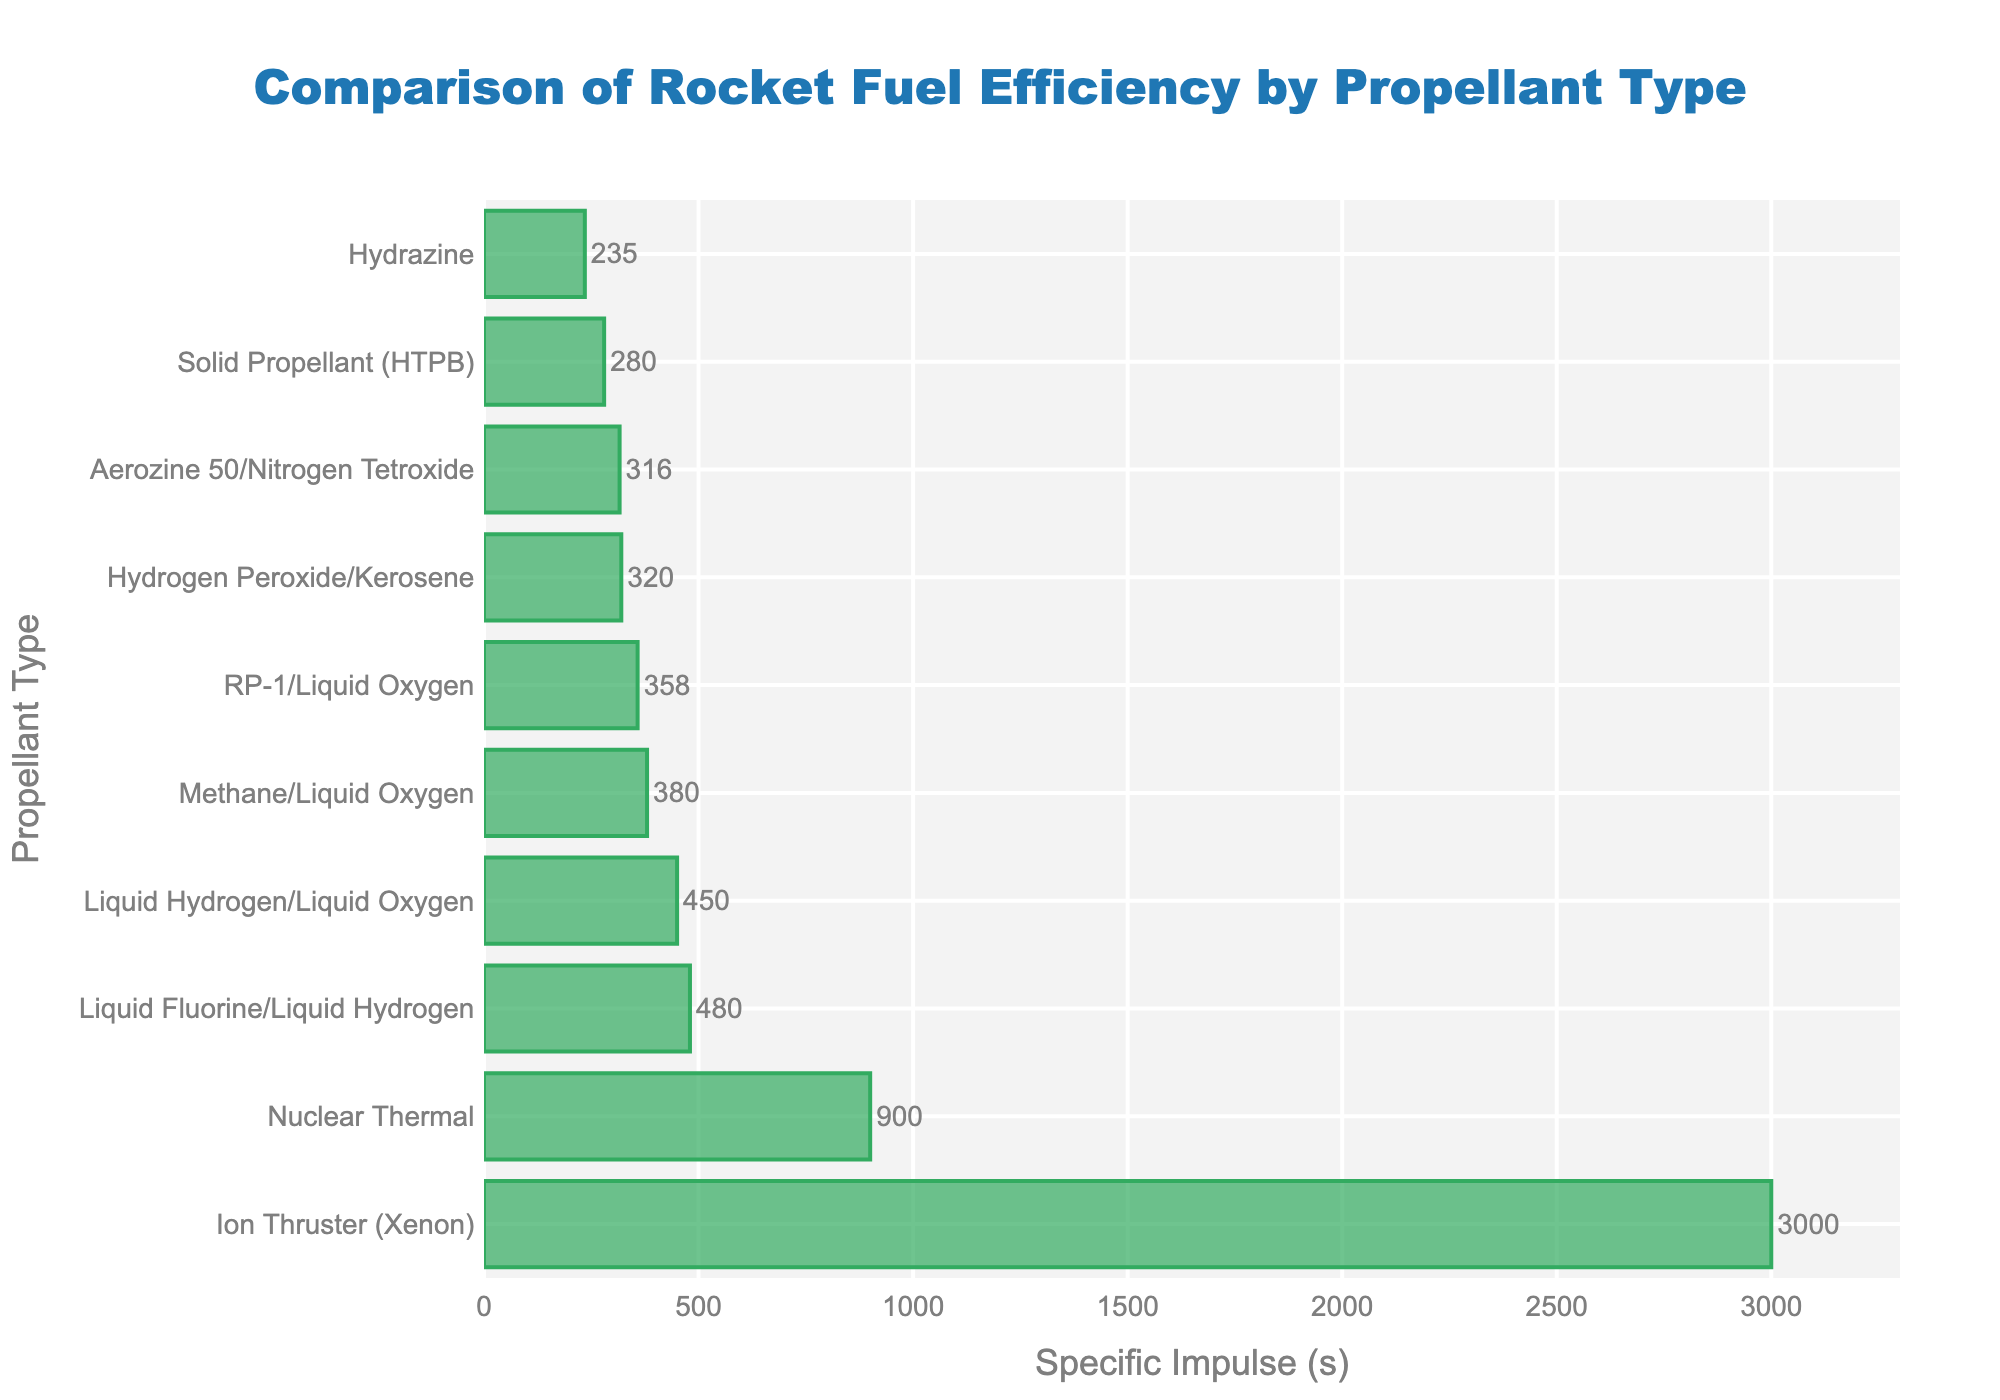What is the specific impulse of the propellant type with the highest efficiency? The bar chart shows each propellant type along with its specific impulse value. The longest bar represents the propellant type with the highest specific impulse, which is the Ion Thruster (Xenon) with a specific impulse of 3000 seconds.
Answer: 3000 seconds Which propellant type has a higher specific impulse, Methane/Liquid Oxygen or RP-1/Liquid Oxygen? By visually comparing the lengths of the bars for Methane/Liquid Oxygen and RP-1/Liquid Oxygen, we can see that Methane/Liquid Oxygen has a longer bar, indicating a higher specific impulse (380 seconds) than RP-1/Liquid Oxygen (358 seconds).
Answer: Methane/Liquid Oxygen How much greater is the specific impulse of Liquid Hydrogen/Liquid Oxygen compared to Solid Propellant (HTPB)? The specific impulse of Liquid Hydrogen/Liquid Oxygen is 450 seconds, and for Solid Propellant (HTPB), it is 280 seconds. To find the difference, we subtract 280 from 450, which is 170 seconds.
Answer: 170 seconds What is the average specific impulse of propellant types with values less than 300 seconds? The propellant types with specific impulses less than 300 seconds are Hydrazine (235 seconds), Solid Propellant (HTPB) (280 seconds), Ion Thruster (Xenon) (3000 seconds), and Aerozine 50/Nitrogen Tetroxide (316 seconds). Summing their specific impulses gives 235 + 280 = 515. Since there are 2 values, we find the average by dividing by 2, which is 257.5 seconds.
Answer: 257.5 seconds Which two propellant types have the closest specific impulses? By closely examining the lengths of the bars, we find that Hydrogen Peroxide/Kerosene (320 seconds) and Aerozine 50/Nitrogen Tetroxide (316 seconds) have very close specific impulse values.
Answer: Hydrogen Peroxide/Kerosene and Aerozine 50/Nitrogen Tetroxide Which propellant type ranks third in specific impulse, and what is its value? Sorting the lengths of the bars in descending order, the third longest bar corresponds to Nuclear Thermal with a specific impulse of 900 seconds.
Answer: Nuclear Thermal, 900 seconds How many propellant types have a specific impulse greater than 400 seconds? By counting the propellant types with bars extending beyond the 400-second mark on the X-axis, we find that there are three: Liquid Fluorine/Liquid Hydrogen (480 seconds), Liquid Hydrogen/Liquid Oxygen (450 seconds), and Ion Thruster (Xenon) (3000 seconds).
Answer: Three If we combine the specific impulse values of RP-1/Liquid Oxygen and Hydrazine, what is the total? The specific impulse of RP-1/Liquid Oxygen is 358 seconds, and Hydrazine is 235 seconds. Adding these together gives 358 + 235 = 593 seconds.
Answer: 593 seconds 